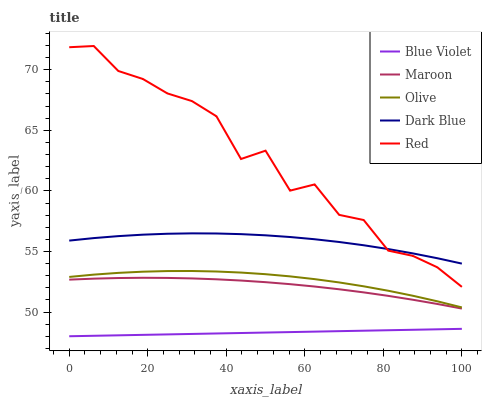Does Blue Violet have the minimum area under the curve?
Answer yes or no. Yes. Does Red have the maximum area under the curve?
Answer yes or no. Yes. Does Dark Blue have the minimum area under the curve?
Answer yes or no. No. Does Dark Blue have the maximum area under the curve?
Answer yes or no. No. Is Blue Violet the smoothest?
Answer yes or no. Yes. Is Red the roughest?
Answer yes or no. Yes. Is Dark Blue the smoothest?
Answer yes or no. No. Is Dark Blue the roughest?
Answer yes or no. No. Does Red have the lowest value?
Answer yes or no. No. Does Dark Blue have the highest value?
Answer yes or no. No. Is Maroon less than Dark Blue?
Answer yes or no. Yes. Is Red greater than Olive?
Answer yes or no. Yes. Does Maroon intersect Dark Blue?
Answer yes or no. No. 